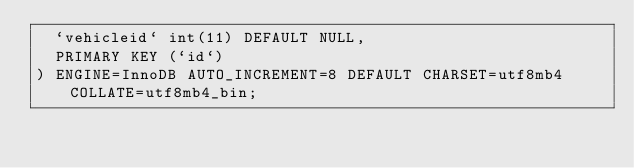Convert code to text. <code><loc_0><loc_0><loc_500><loc_500><_SQL_>  `vehicleid` int(11) DEFAULT NULL,
  PRIMARY KEY (`id`)
) ENGINE=InnoDB AUTO_INCREMENT=8 DEFAULT CHARSET=utf8mb4 COLLATE=utf8mb4_bin;
</code> 